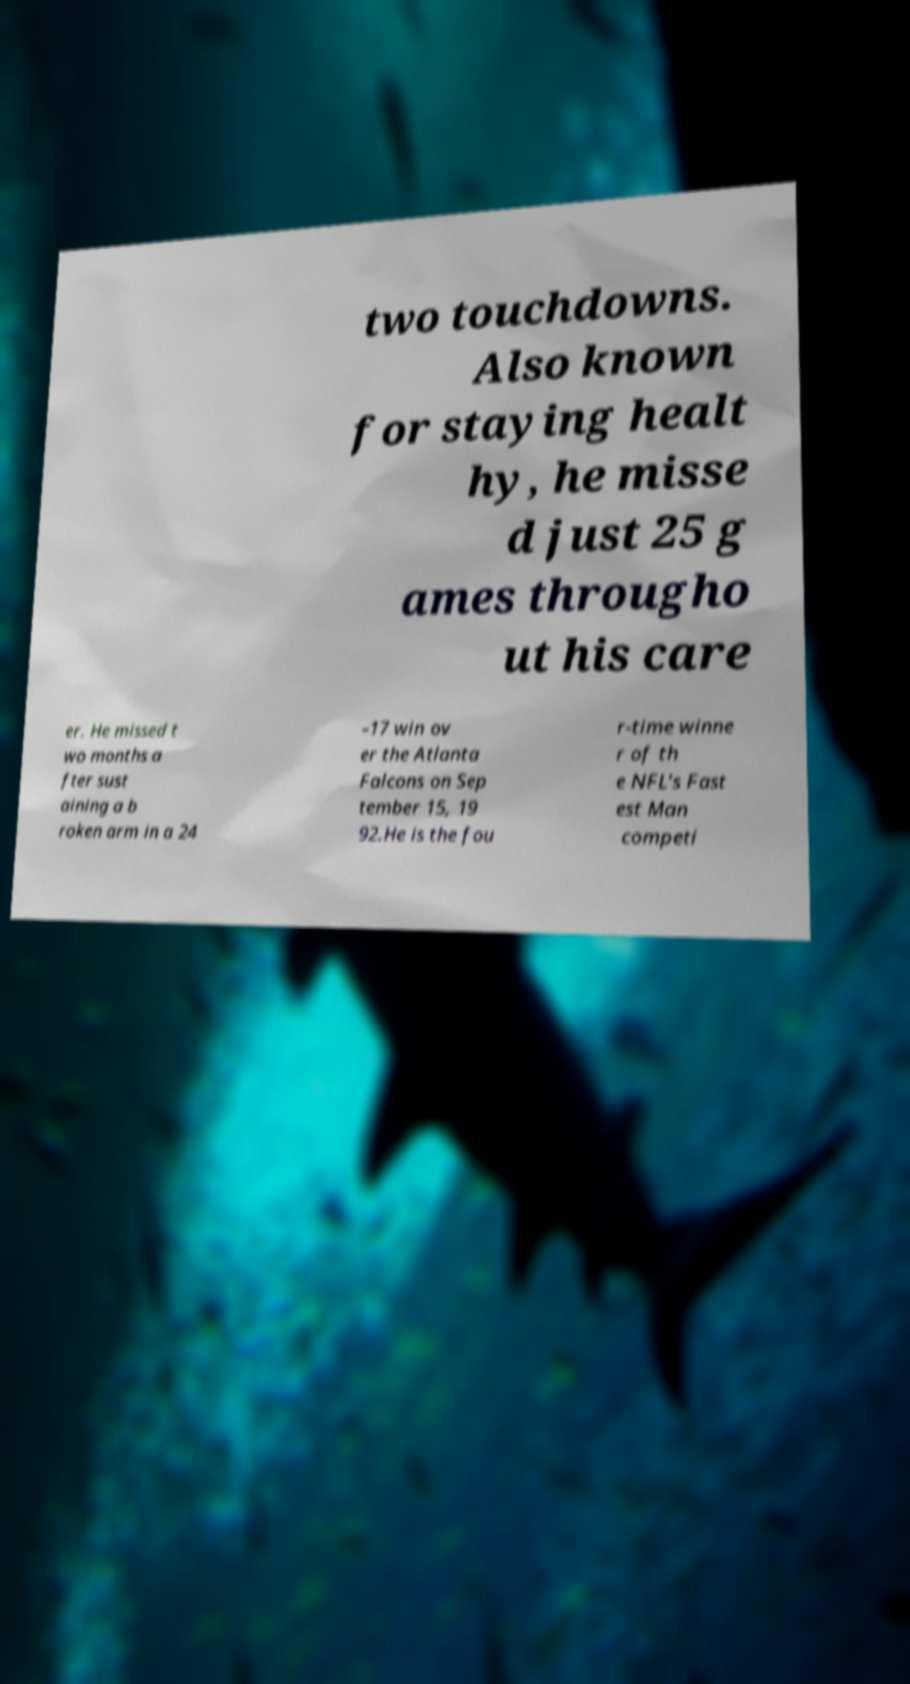What messages or text are displayed in this image? I need them in a readable, typed format. two touchdowns. Also known for staying healt hy, he misse d just 25 g ames througho ut his care er. He missed t wo months a fter sust aining a b roken arm in a 24 –17 win ov er the Atlanta Falcons on Sep tember 15, 19 92.He is the fou r-time winne r of th e NFL's Fast est Man competi 